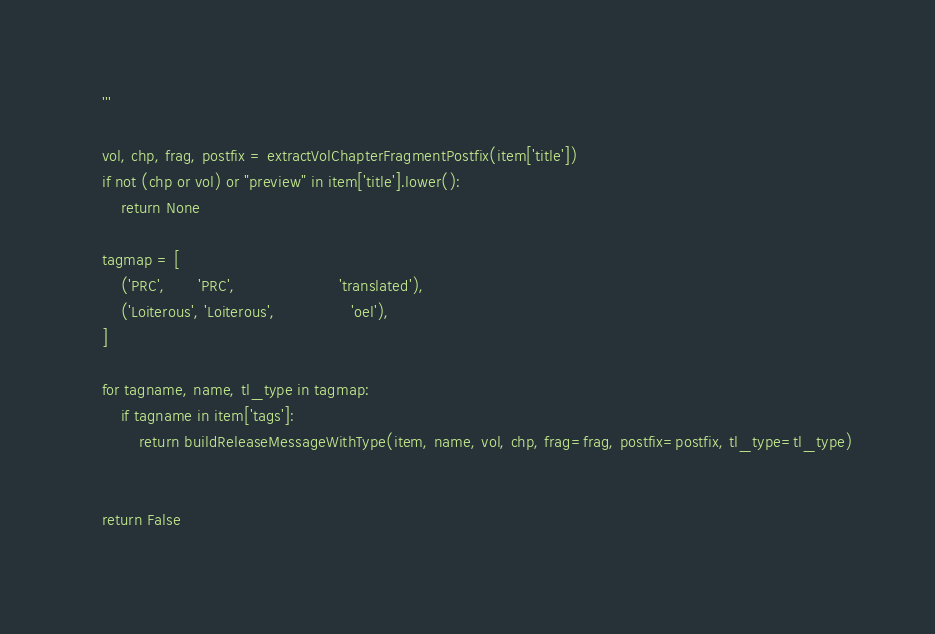Convert code to text. <code><loc_0><loc_0><loc_500><loc_500><_Python_>	'''

	vol, chp, frag, postfix = extractVolChapterFragmentPostfix(item['title'])
	if not (chp or vol) or "preview" in item['title'].lower():
		return None

	tagmap = [
		('PRC',       'PRC',                      'translated'),
		('Loiterous', 'Loiterous',                'oel'),
	]

	for tagname, name, tl_type in tagmap:
		if tagname in item['tags']:
			return buildReleaseMessageWithType(item, name, vol, chp, frag=frag, postfix=postfix, tl_type=tl_type)


	return False
	</code> 